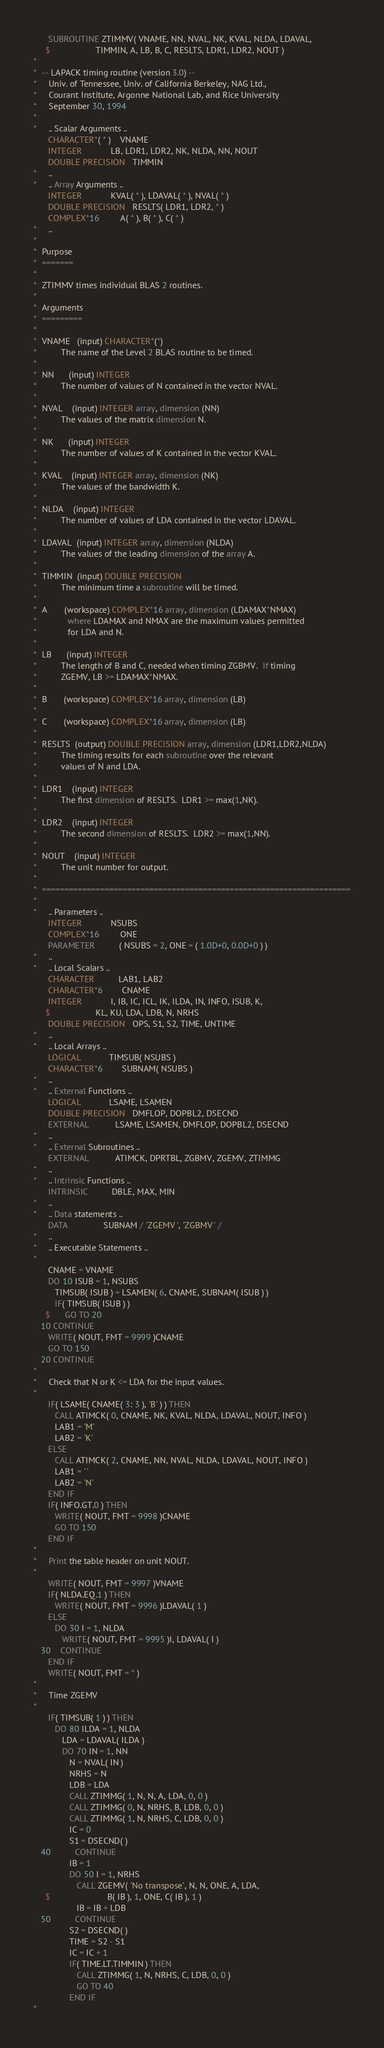Convert code to text. <code><loc_0><loc_0><loc_500><loc_500><_FORTRAN_>      SUBROUTINE ZTIMMV( VNAME, NN, NVAL, NK, KVAL, NLDA, LDAVAL,
     $                   TIMMIN, A, LB, B, C, RESLTS, LDR1, LDR2, NOUT )
*
*  -- LAPACK timing routine (version 3.0) --
*     Univ. of Tennessee, Univ. of California Berkeley, NAG Ltd.,
*     Courant Institute, Argonne National Lab, and Rice University
*     September 30, 1994
*
*     .. Scalar Arguments ..
      CHARACTER*( * )    VNAME
      INTEGER            LB, LDR1, LDR2, NK, NLDA, NN, NOUT
      DOUBLE PRECISION   TIMMIN
*     ..
*     .. Array Arguments ..
      INTEGER            KVAL( * ), LDAVAL( * ), NVAL( * )
      DOUBLE PRECISION   RESLTS( LDR1, LDR2, * )
      COMPLEX*16         A( * ), B( * ), C( * )
*     ..
*
*  Purpose
*  =======
*
*  ZTIMMV times individual BLAS 2 routines.
*
*  Arguments
*  =========
*
*  VNAME   (input) CHARACTER*(*)
*          The name of the Level 2 BLAS routine to be timed.
*
*  NN      (input) INTEGER
*          The number of values of N contained in the vector NVAL.
*
*  NVAL    (input) INTEGER array, dimension (NN)
*          The values of the matrix dimension N.
*
*  NK      (input) INTEGER
*          The number of values of K contained in the vector KVAL.
*
*  KVAL    (input) INTEGER array, dimension (NK)
*          The values of the bandwidth K.
*
*  NLDA    (input) INTEGER
*          The number of values of LDA contained in the vector LDAVAL.
*
*  LDAVAL  (input) INTEGER array, dimension (NLDA)
*          The values of the leading dimension of the array A.
*
*  TIMMIN  (input) DOUBLE PRECISION
*          The minimum time a subroutine will be timed.
*
*  A       (workspace) COMPLEX*16 array, dimension (LDAMAX*NMAX)
*             where LDAMAX and NMAX are the maximum values permitted
*             for LDA and N.
*
*  LB      (input) INTEGER
*          The length of B and C, needed when timing ZGBMV.  If timing
*          ZGEMV, LB >= LDAMAX*NMAX.
*
*  B       (workspace) COMPLEX*16 array, dimension (LB)
*
*  C       (workspace) COMPLEX*16 array, dimension (LB)
*
*  RESLTS  (output) DOUBLE PRECISION array, dimension (LDR1,LDR2,NLDA)
*          The timing results for each subroutine over the relevant
*          values of N and LDA.
*
*  LDR1    (input) INTEGER
*          The first dimension of RESLTS.  LDR1 >= max(1,NK).
*
*  LDR2    (input) INTEGER
*          The second dimension of RESLTS.  LDR2 >= max(1,NN).
*
*  NOUT    (input) INTEGER
*          The unit number for output.
*
*  =====================================================================
*
*     .. Parameters ..
      INTEGER            NSUBS
      COMPLEX*16         ONE
      PARAMETER          ( NSUBS = 2, ONE = ( 1.0D+0, 0.0D+0 ) )
*     ..
*     .. Local Scalars ..
      CHARACTER          LAB1, LAB2
      CHARACTER*6        CNAME
      INTEGER            I, IB, IC, ICL, IK, ILDA, IN, INFO, ISUB, K,
     $                   KL, KU, LDA, LDB, N, NRHS
      DOUBLE PRECISION   OPS, S1, S2, TIME, UNTIME
*     ..
*     .. Local Arrays ..
      LOGICAL            TIMSUB( NSUBS )
      CHARACTER*6        SUBNAM( NSUBS )
*     ..
*     .. External Functions ..
      LOGICAL            LSAME, LSAMEN
      DOUBLE PRECISION   DMFLOP, DOPBL2, DSECND
      EXTERNAL           LSAME, LSAMEN, DMFLOP, DOPBL2, DSECND
*     ..
*     .. External Subroutines ..
      EXTERNAL           ATIMCK, DPRTBL, ZGBMV, ZGEMV, ZTIMMG
*     ..
*     .. Intrinsic Functions ..
      INTRINSIC          DBLE, MAX, MIN
*     ..
*     .. Data statements ..
      DATA               SUBNAM / 'ZGEMV ', 'ZGBMV ' /
*     ..
*     .. Executable Statements ..
*
      CNAME = VNAME
      DO 10 ISUB = 1, NSUBS
         TIMSUB( ISUB ) = LSAMEN( 6, CNAME, SUBNAM( ISUB ) )
         IF( TIMSUB( ISUB ) )
     $      GO TO 20
   10 CONTINUE
      WRITE( NOUT, FMT = 9999 )CNAME
      GO TO 150
   20 CONTINUE
*
*     Check that N or K <= LDA for the input values.
*
      IF( LSAME( CNAME( 3: 3 ), 'B' ) ) THEN
         CALL ATIMCK( 0, CNAME, NK, KVAL, NLDA, LDAVAL, NOUT, INFO )
         LAB1 = 'M'
         LAB2 = 'K'
      ELSE
         CALL ATIMCK( 2, CNAME, NN, NVAL, NLDA, LDAVAL, NOUT, INFO )
         LAB1 = ' '
         LAB2 = 'N'
      END IF
      IF( INFO.GT.0 ) THEN
         WRITE( NOUT, FMT = 9998 )CNAME
         GO TO 150
      END IF
*
*     Print the table header on unit NOUT.
*
      WRITE( NOUT, FMT = 9997 )VNAME
      IF( NLDA.EQ.1 ) THEN
         WRITE( NOUT, FMT = 9996 )LDAVAL( 1 )
      ELSE
         DO 30 I = 1, NLDA
            WRITE( NOUT, FMT = 9995 )I, LDAVAL( I )
   30    CONTINUE
      END IF
      WRITE( NOUT, FMT = * )
*
*     Time ZGEMV
*
      IF( TIMSUB( 1 ) ) THEN
         DO 80 ILDA = 1, NLDA
            LDA = LDAVAL( ILDA )
            DO 70 IN = 1, NN
               N = NVAL( IN )
               NRHS = N
               LDB = LDA
               CALL ZTIMMG( 1, N, N, A, LDA, 0, 0 )
               CALL ZTIMMG( 0, N, NRHS, B, LDB, 0, 0 )
               CALL ZTIMMG( 1, N, NRHS, C, LDB, 0, 0 )
               IC = 0
               S1 = DSECND( )
   40          CONTINUE
               IB = 1
               DO 50 I = 1, NRHS
                  CALL ZGEMV( 'No transpose', N, N, ONE, A, LDA,
     $                        B( IB ), 1, ONE, C( IB ), 1 )
                  IB = IB + LDB
   50          CONTINUE
               S2 = DSECND( )
               TIME = S2 - S1
               IC = IC + 1
               IF( TIME.LT.TIMMIN ) THEN
                  CALL ZTIMMG( 1, N, NRHS, C, LDB, 0, 0 )
                  GO TO 40
               END IF
*</code> 